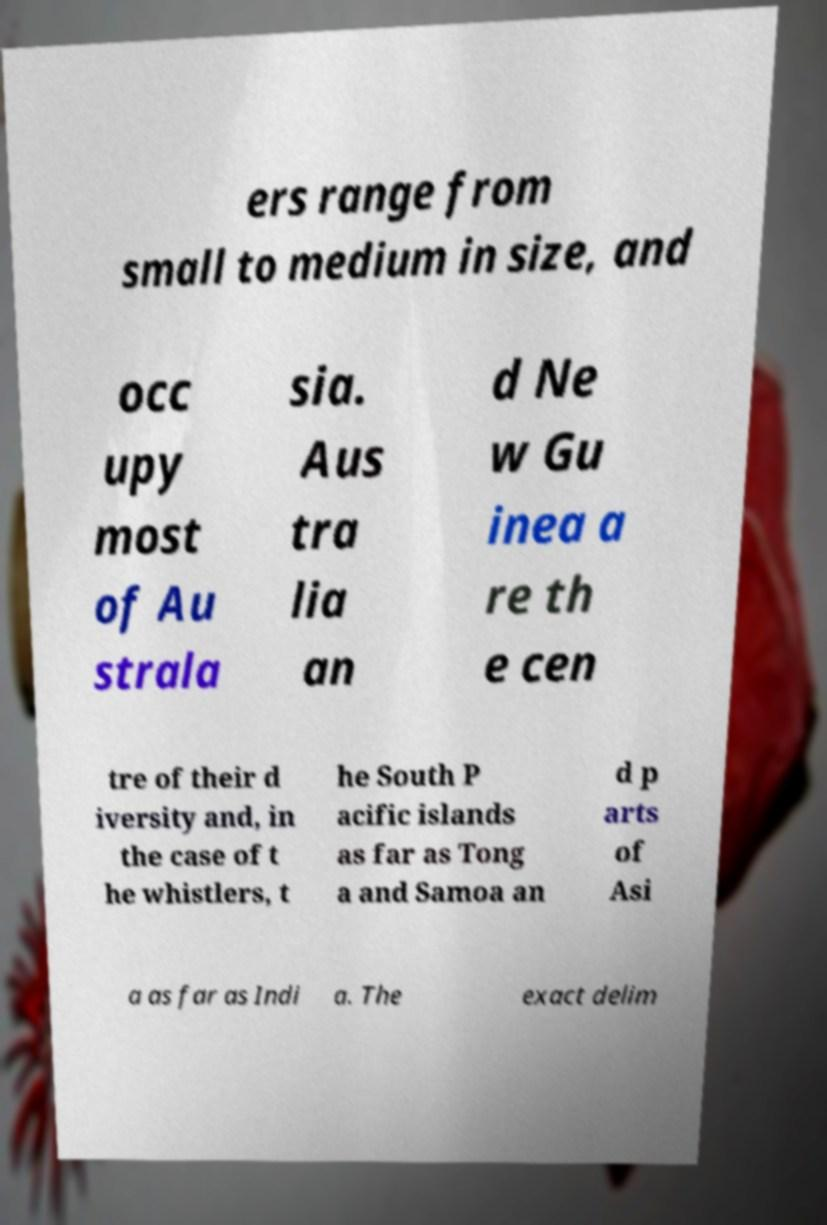I need the written content from this picture converted into text. Can you do that? ers range from small to medium in size, and occ upy most of Au strala sia. Aus tra lia an d Ne w Gu inea a re th e cen tre of their d iversity and, in the case of t he whistlers, t he South P acific islands as far as Tong a and Samoa an d p arts of Asi a as far as Indi a. The exact delim 